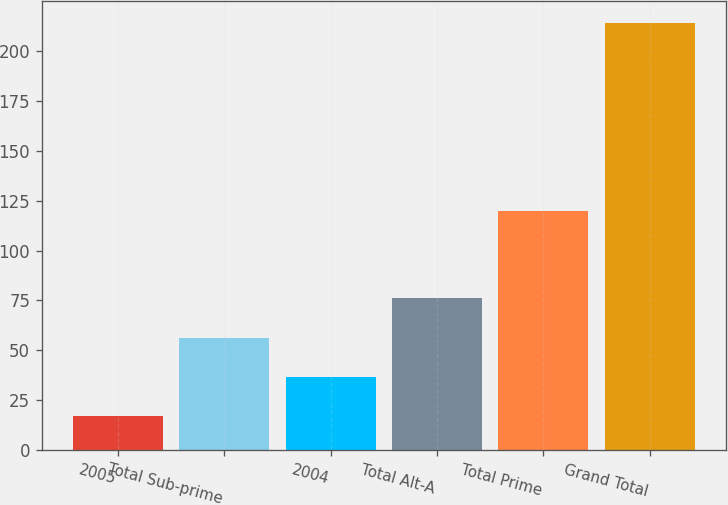Convert chart. <chart><loc_0><loc_0><loc_500><loc_500><bar_chart><fcel>2005<fcel>Total Sub-prime<fcel>2004<fcel>Total Alt-A<fcel>Total Prime<fcel>Grand Total<nl><fcel>17<fcel>56.4<fcel>36.7<fcel>76.1<fcel>120<fcel>214<nl></chart> 